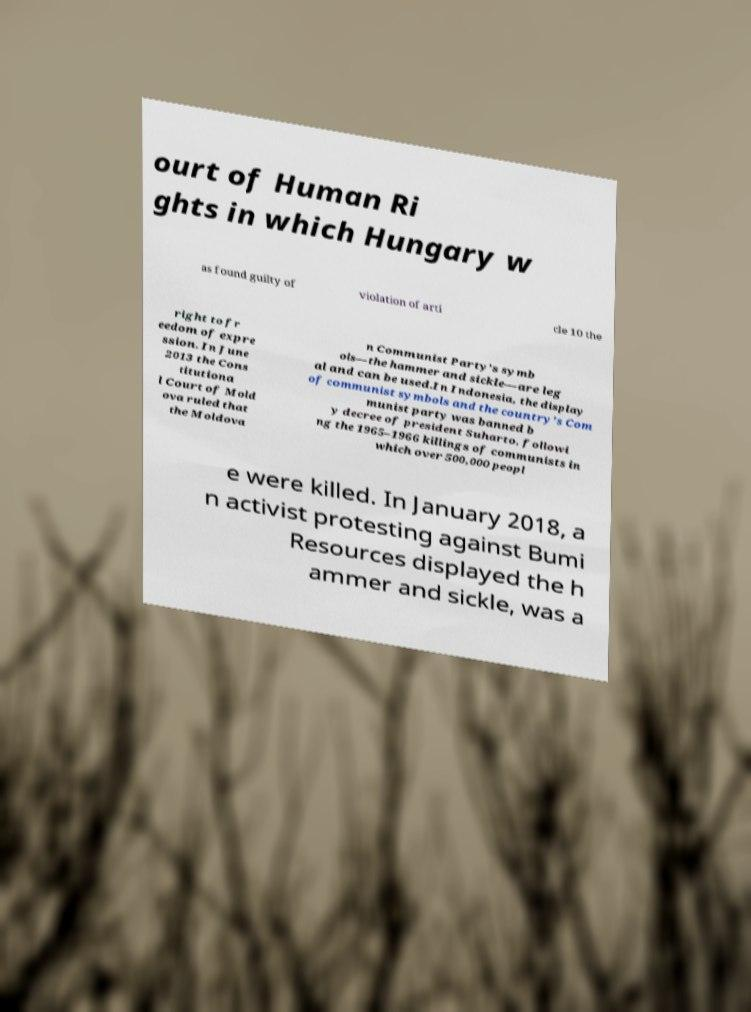Please identify and transcribe the text found in this image. ourt of Human Ri ghts in which Hungary w as found guilty of violation of arti cle 10 the right to fr eedom of expre ssion. In June 2013 the Cons titutiona l Court of Mold ova ruled that the Moldova n Communist Party’s symb ols—the hammer and sickle—are leg al and can be used.In Indonesia, the display of communist symbols and the country's Com munist party was banned b y decree of president Suharto, followi ng the 1965–1966 killings of communists in which over 500,000 peopl e were killed. In January 2018, a n activist protesting against Bumi Resources displayed the h ammer and sickle, was a 